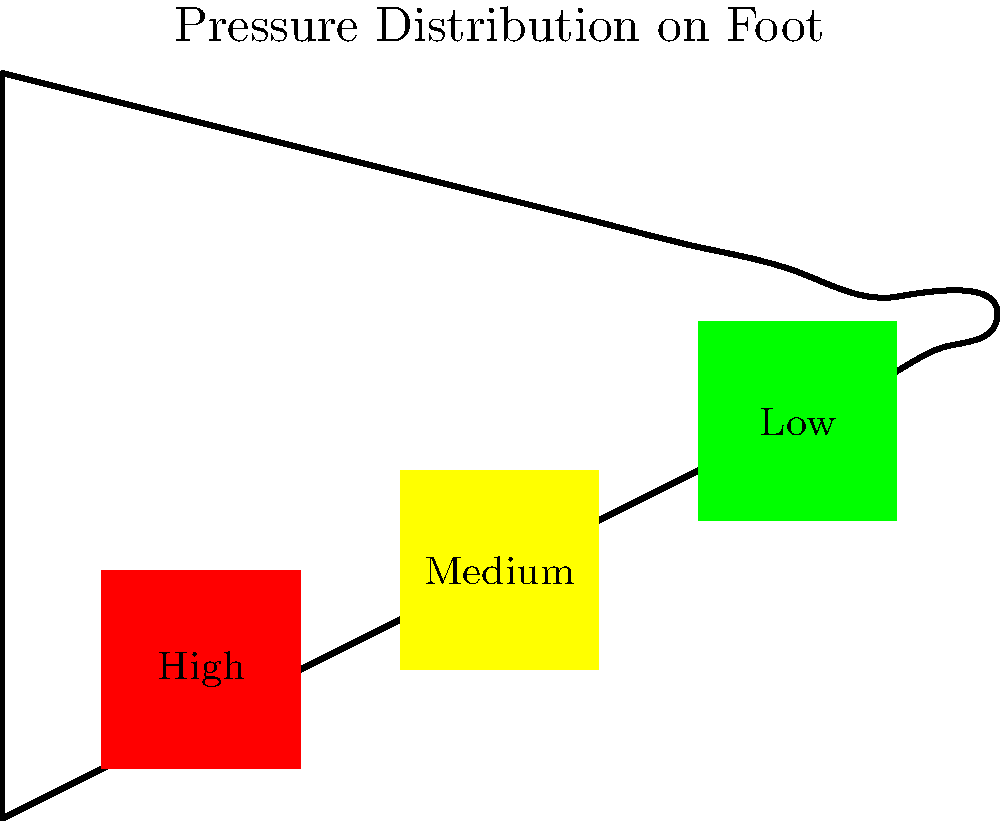As a librarian organizing biomechanical data, you come across a heat map representation of plantar pressure distribution during standing. Which area of the foot typically experiences the highest pressure, as indicated by the red region in the image? To answer this question, let's analyze the heat map representation of plantar pressure distribution:

1. The foot is divided into three main regions: heel, midfoot, and toes.
2. Each region is color-coded to represent different pressure levels:
   - Red indicates high pressure
   - Yellow indicates medium pressure
   - Green indicates low pressure
3. Observing the image, we can see that:
   - The heel area is colored red
   - The midfoot area is colored yellow
   - The toe area is colored green
4. In biomechanics, it's known that during standing:
   - The heel typically bears the most weight
   - The midfoot distributes some of the pressure
   - The toes usually experience the least pressure
5. The red coloration in the heel area confirms this biomechanical principle, indicating the highest pressure concentration.

Therefore, based on the heat map and biomechanical principles, the heel experiences the highest pressure during standing.
Answer: Heel 